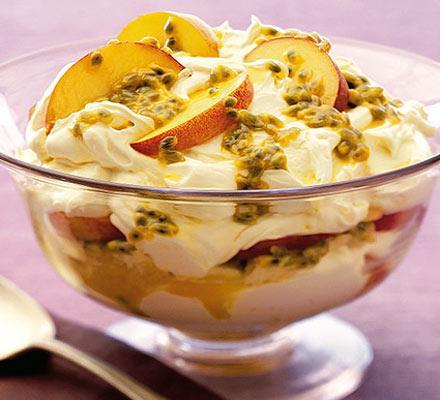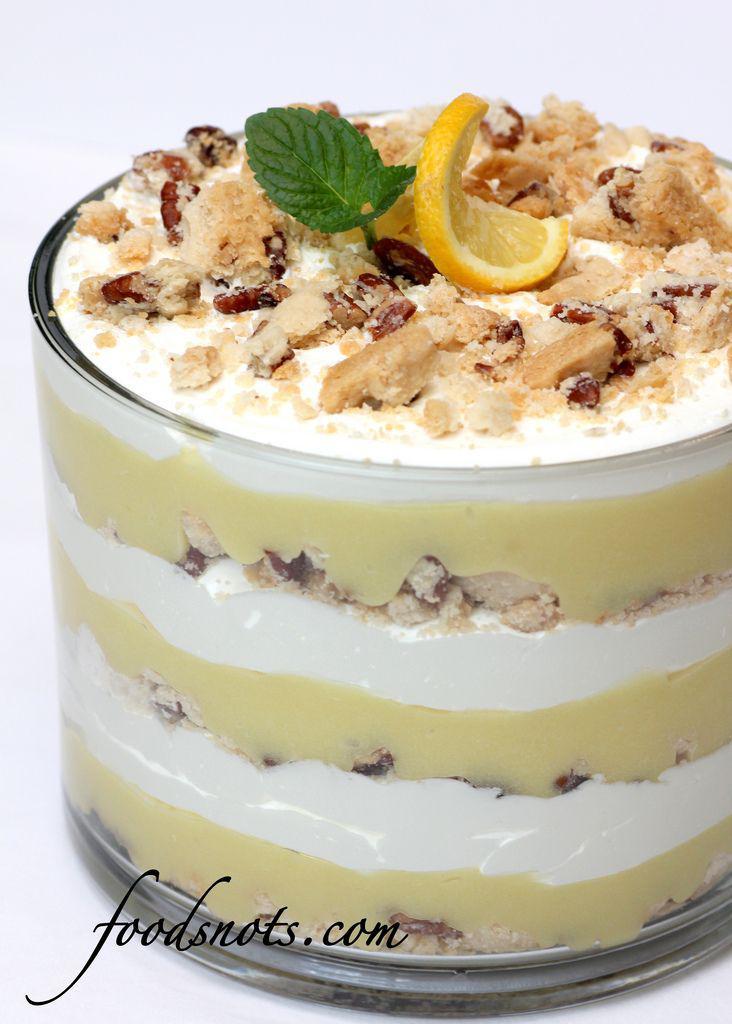The first image is the image on the left, the second image is the image on the right. Given the left and right images, does the statement "Two large multi-layered desserts have been prepared in clear glass footed bowls" hold true? Answer yes or no. No. 